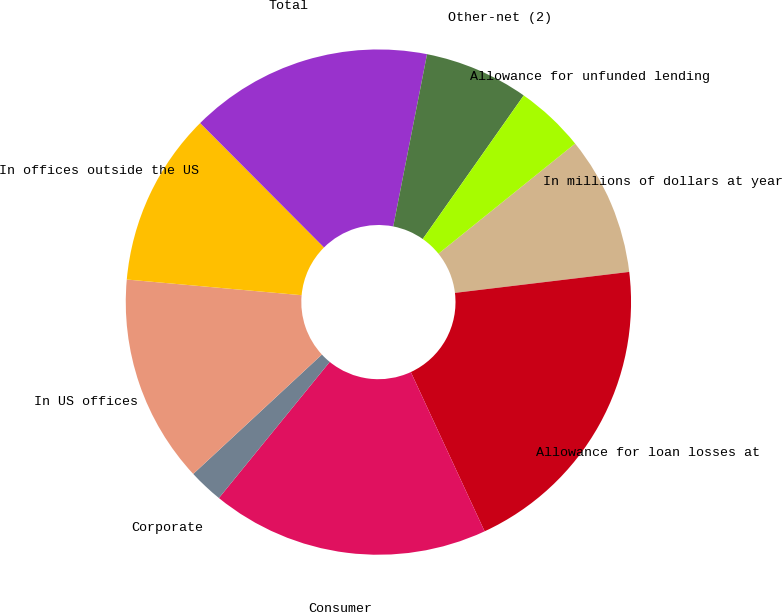Convert chart to OTSL. <chart><loc_0><loc_0><loc_500><loc_500><pie_chart><fcel>In millions of dollars at year<fcel>Allowance for loan losses at<fcel>Consumer<fcel>Corporate<fcel>In US offices<fcel>In offices outside the US<fcel>Total<fcel>Other-net (2)<fcel>Allowance for unfunded lending<nl><fcel>8.89%<fcel>20.0%<fcel>17.78%<fcel>2.22%<fcel>13.33%<fcel>11.11%<fcel>15.55%<fcel>6.67%<fcel>4.45%<nl></chart> 